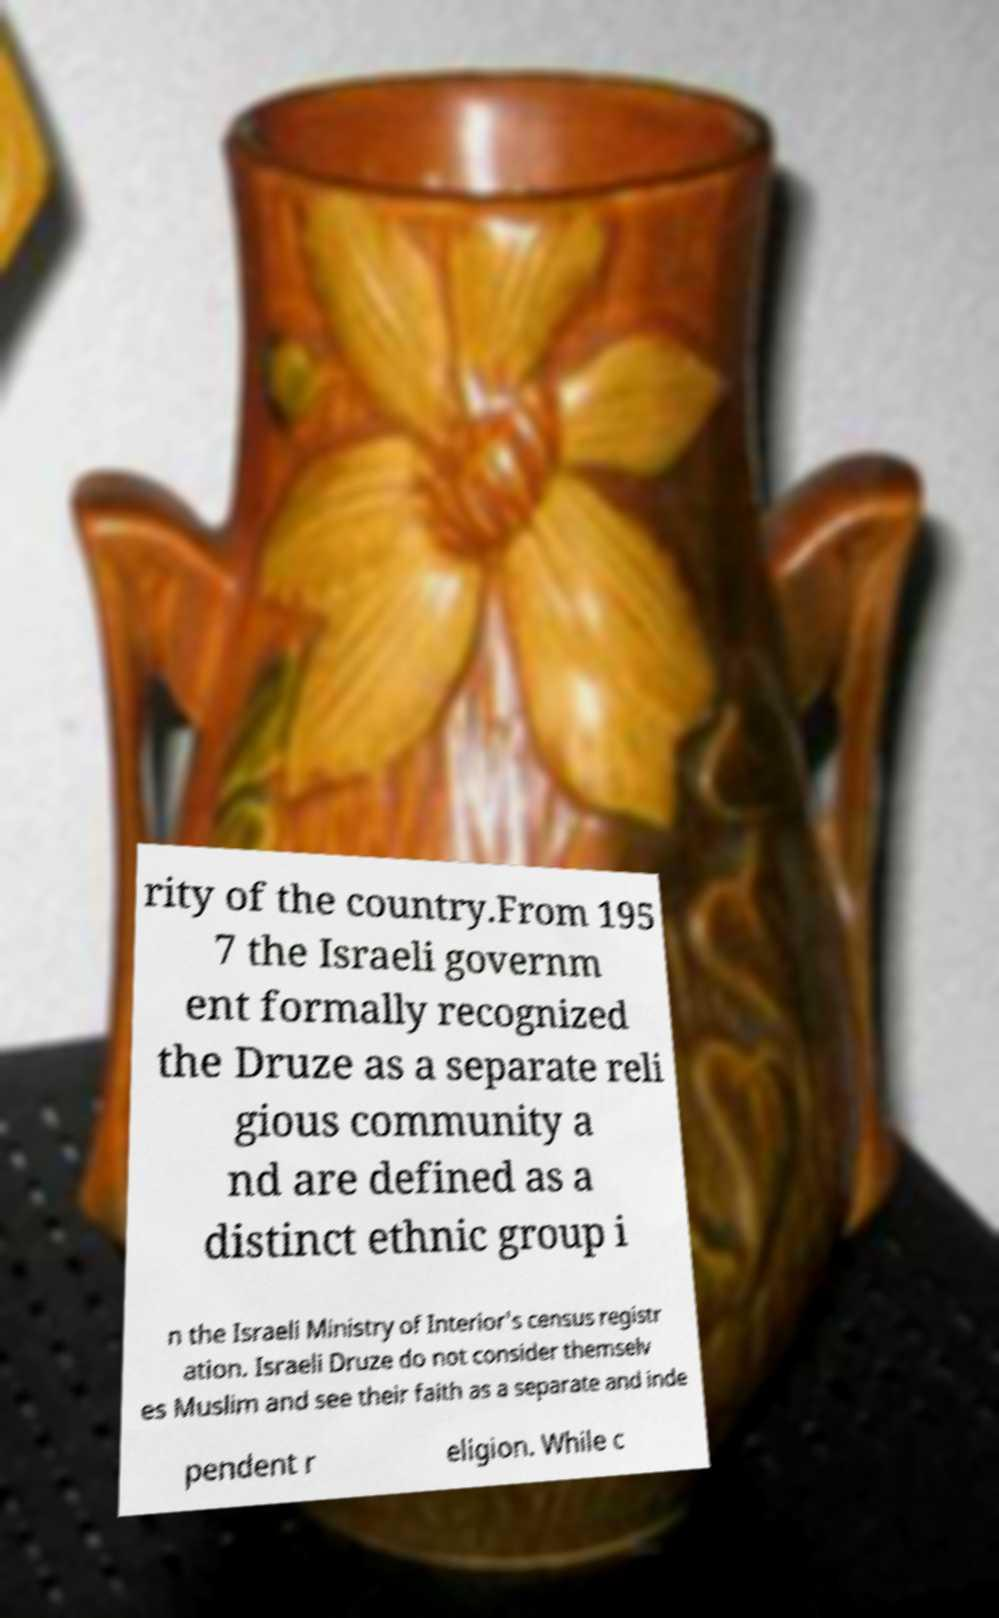I need the written content from this picture converted into text. Can you do that? rity of the country.From 195 7 the Israeli governm ent formally recognized the Druze as a separate reli gious community a nd are defined as a distinct ethnic group i n the Israeli Ministry of Interior's census registr ation. Israeli Druze do not consider themselv es Muslim and see their faith as a separate and inde pendent r eligion. While c 